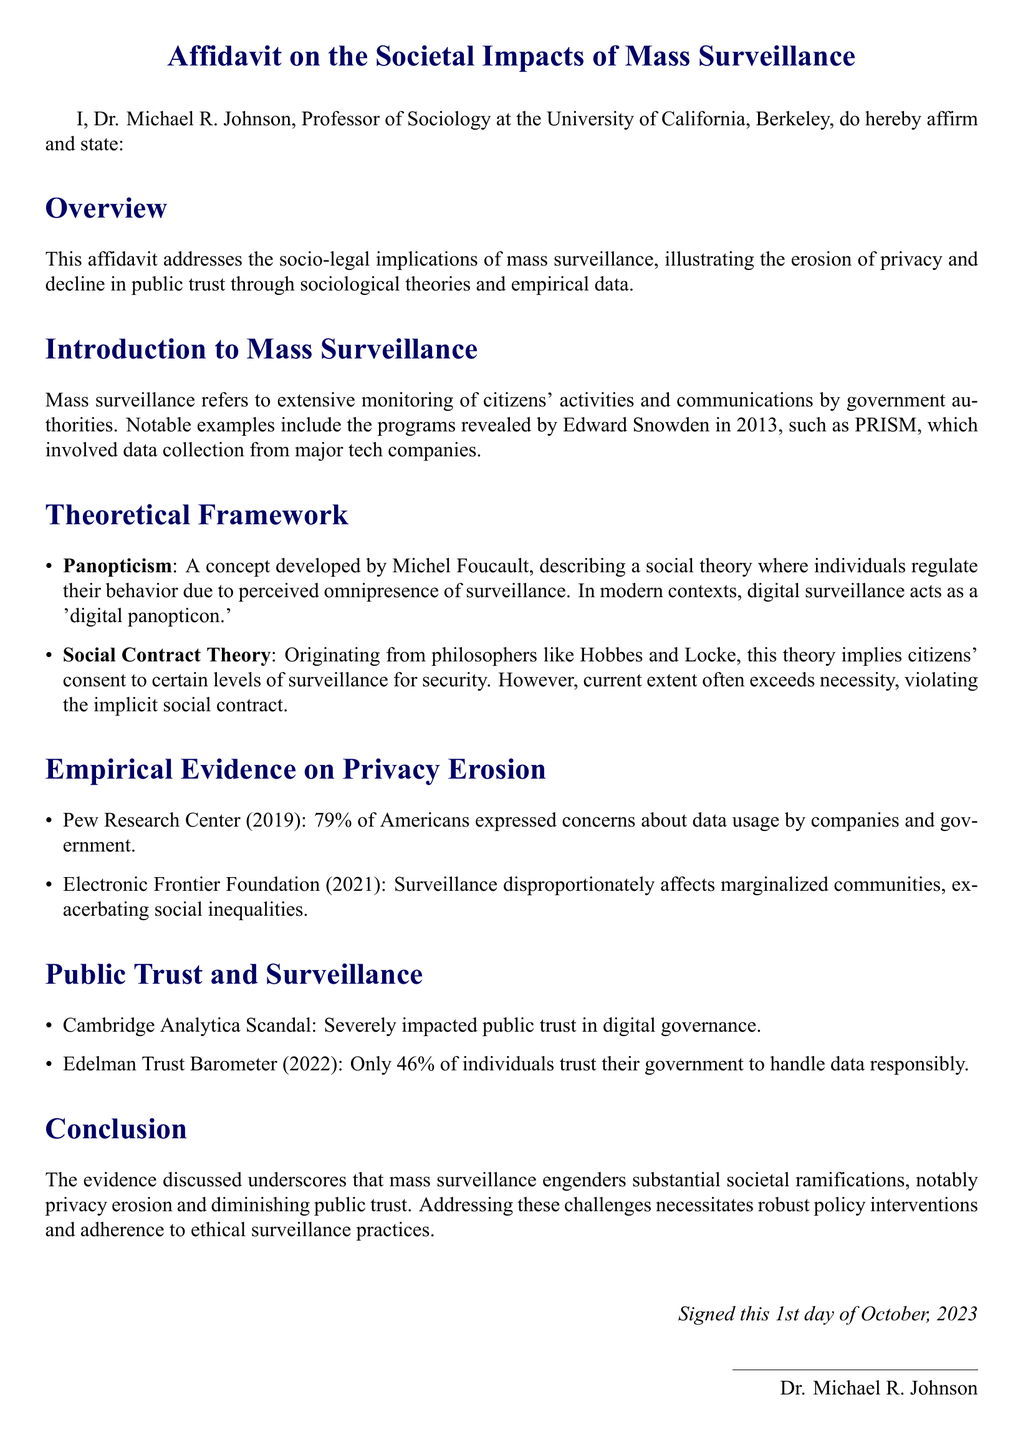What is the author's name? The author's name is stated at the beginning of the affidavit as Dr. Michael R. Johnson.
Answer: Dr. Michael R. Johnson What year was the Cambridge Analytica scandal addressed? The affidavit references the Cambridge Analytica scandal, which impacted public trust; the context does not specify a year, but it is widely known to have occurred in 2016.
Answer: 2016 What percentage of Americans expressed concerns about data usage according to Pew Research Center? The document states that 79% of Americans are concerned about data usage by companies and government as per Pew Research Center (2019).
Answer: 79% What does the term "digital panopticon" refer to in the affidavit? The term "digital panopticon" is used in the context of Panopticism, indicating a modern form where individuals regulate behavior due to perceived surveillance.
Answer: Digital panopticon Which sociological theory implies citizens' consent to levels of surveillance? The sociological theory that suggests citizens' consent is Social Contract Theory, originating from philosophers like Hobbes and Locke.
Answer: Social Contract Theory What was the percentage of individuals who trust their government to handle data responsibly according to the Edelman Trust Barometer? The document states that according to the Edelman Trust Barometer (2022), only 46% of individuals trust their government to handle data responsibly.
Answer: 46% What is the date on which the affidavit was signed? The affidavit specifies that it was signed on the 1st day of October, 2023.
Answer: 1st day of October, 2023 Who is the affiliated institution of the author? The institution the author is affiliated with is the University of California, Berkeley.
Answer: University of California, Berkeley What impact did mass surveillance have on marginalized communities according to the Electronic Frontier Foundation? The affidavit mentions that surveillance disproportionately affects marginalized communities, exacerbating social inequalities.
Answer: Exacerbating social inequalities 